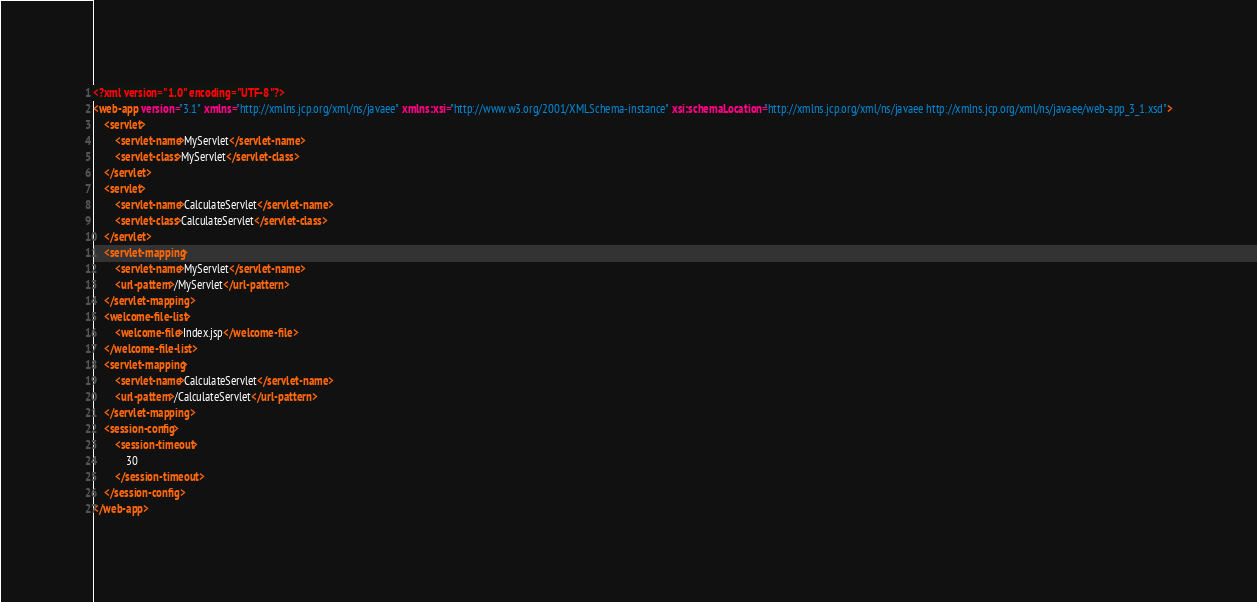Convert code to text. <code><loc_0><loc_0><loc_500><loc_500><_XML_><?xml version="1.0" encoding="UTF-8"?>
<web-app version="3.1" xmlns="http://xmlns.jcp.org/xml/ns/javaee" xmlns:xsi="http://www.w3.org/2001/XMLSchema-instance" xsi:schemaLocation="http://xmlns.jcp.org/xml/ns/javaee http://xmlns.jcp.org/xml/ns/javaee/web-app_3_1.xsd">
    <servlet>
        <servlet-name>MyServlet</servlet-name>
        <servlet-class>MyServlet</servlet-class>
    </servlet>
    <servlet>
        <servlet-name>CalculateServlet</servlet-name>
        <servlet-class>CalculateServlet</servlet-class>
    </servlet>
    <servlet-mapping>
        <servlet-name>MyServlet</servlet-name>
        <url-pattern>/MyServlet</url-pattern>
    </servlet-mapping>
    <welcome-file-list>
        <welcome-file>Index.jsp</welcome-file>
    </welcome-file-list>
    <servlet-mapping>
        <servlet-name>CalculateServlet</servlet-name>
        <url-pattern>/CalculateServlet</url-pattern>
    </servlet-mapping>
    <session-config>
        <session-timeout>
            30
        </session-timeout>
    </session-config>
</web-app>
</code> 